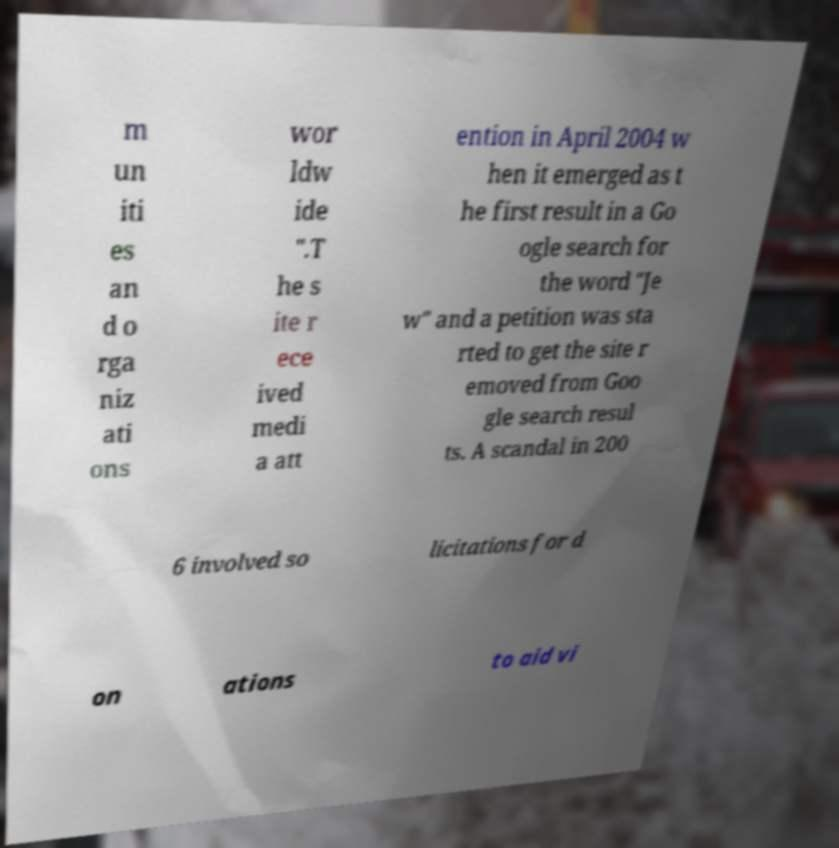Could you assist in decoding the text presented in this image and type it out clearly? m un iti es an d o rga niz ati ons wor ldw ide ".T he s ite r ece ived medi a att ention in April 2004 w hen it emerged as t he first result in a Go ogle search for the word "Je w" and a petition was sta rted to get the site r emoved from Goo gle search resul ts. A scandal in 200 6 involved so licitations for d on ations to aid vi 